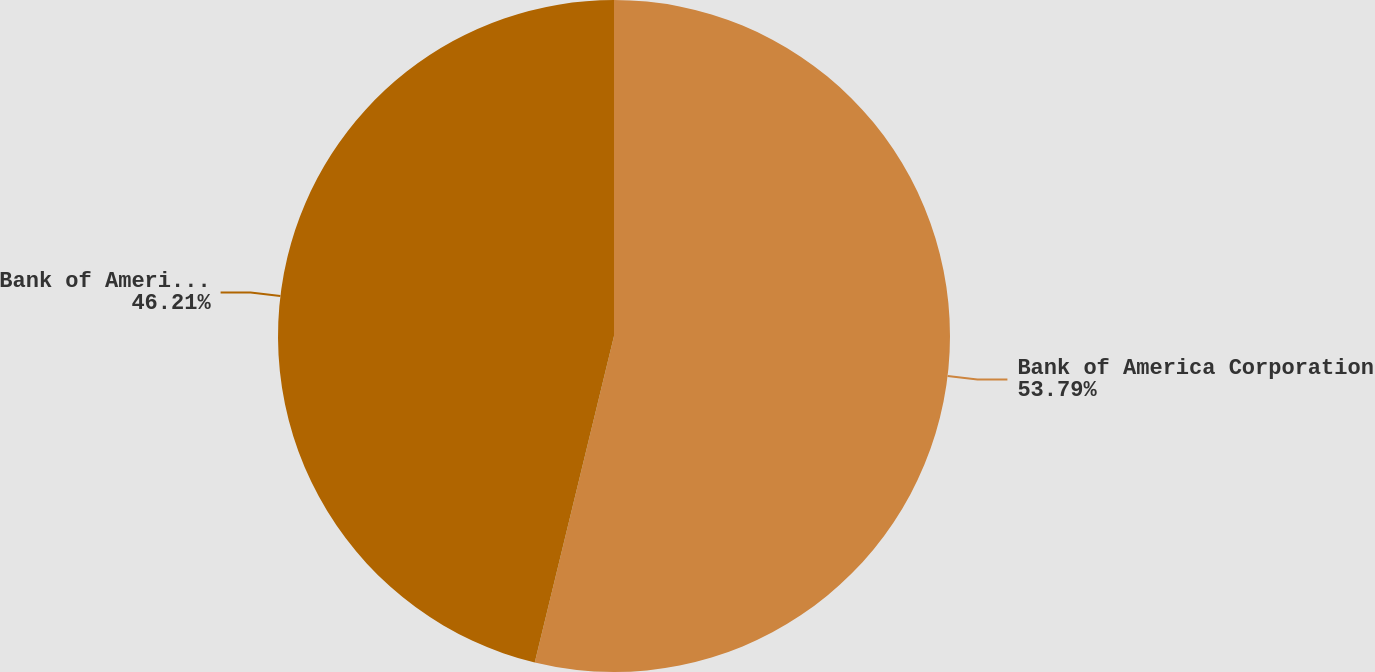<chart> <loc_0><loc_0><loc_500><loc_500><pie_chart><fcel>Bank of America Corporation<fcel>Bank of America NA<nl><fcel>53.79%<fcel>46.21%<nl></chart> 